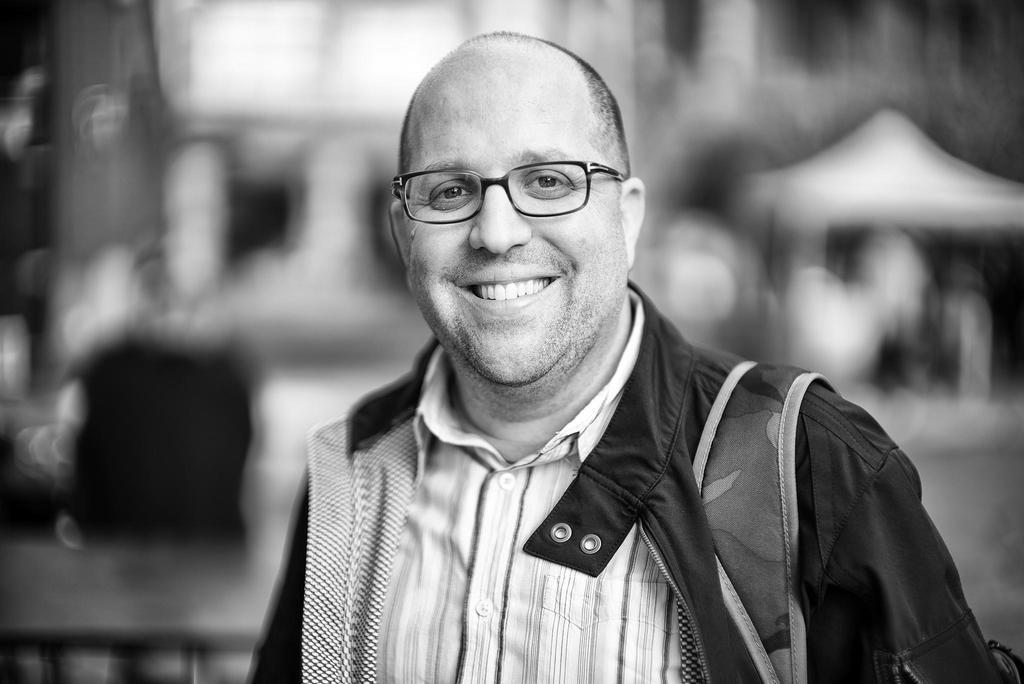What is the color scheme of the image? The image is black and white. Who is present in the image? There is a man in the image. What expression does the man have? The man is smiling. Can you describe the background of the image? The background of the image is blurred. What type of stem can be seen growing in the image? There is no stem present in the image; it is a black and white image of a man with a blurred background. 